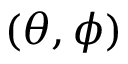Convert formula to latex. <formula><loc_0><loc_0><loc_500><loc_500>( \theta , \phi )</formula> 